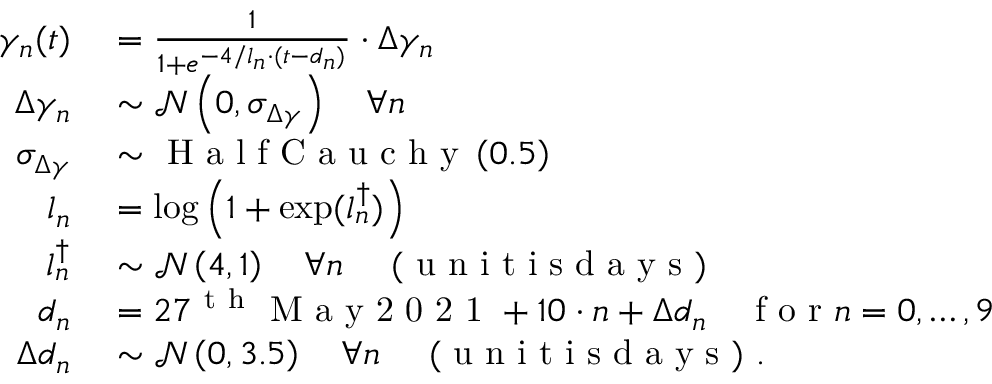Convert formula to latex. <formula><loc_0><loc_0><loc_500><loc_500>\begin{array} { r l } { \gamma _ { n } ( t ) } & = \frac { 1 } { 1 + e ^ { - 4 / l _ { n } \cdot ( t - d _ { n } ) } } \cdot \Delta \gamma _ { n } } \\ { \Delta \gamma _ { n } } & \sim \mathcal { N } \left ( 0 , \sigma _ { \Delta \gamma } \right ) \quad \forall n } \\ { \sigma _ { \Delta \gamma } } & \sim H a l f C a u c h y \left ( 0 . 5 \right ) } \\ { l _ { n } } & = \log \left ( 1 + \exp ( l _ { n } ^ { \dagger } ) \right ) } \\ { l _ { n } ^ { \dagger } } & \sim \mathcal { N } \left ( 4 , 1 \right ) \quad \forall n \quad ( u n i t i s d a y s ) } \\ { d _ { n } } & = 2 7 ^ { t h } M a y 2 0 2 1 + 1 0 \cdot n + \Delta d _ { n } \quad f o r n = { 0 , \dots , 9 } } \\ { \Delta d _ { n } } & \sim \mathcal { N } \left ( 0 , 3 . 5 \right ) \quad \forall n \quad ( u n i t i s d a y s ) . } \end{array}</formula> 